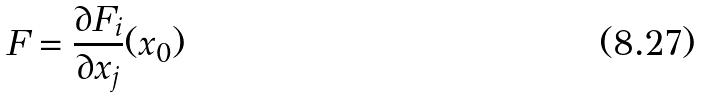Convert formula to latex. <formula><loc_0><loc_0><loc_500><loc_500>F = \frac { \partial F _ { i } } { \partial x _ { j } } ( x _ { 0 } )</formula> 